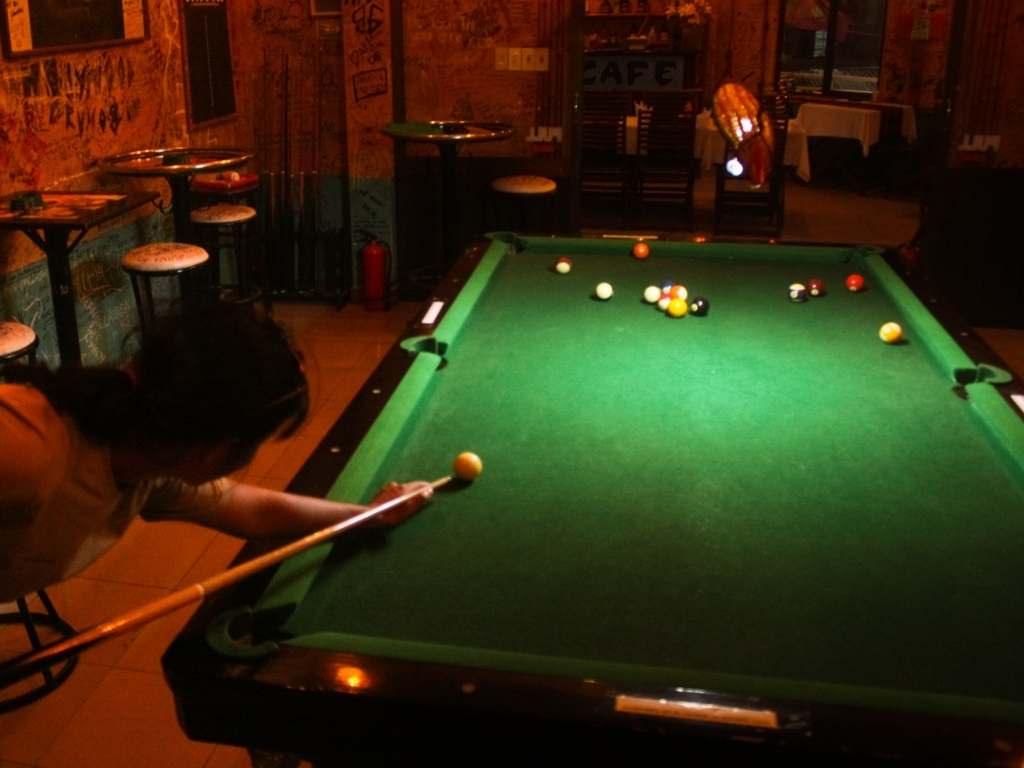What is the atmosphere of the location in the image? The image conveys a casual and relaxed atmosphere, possibly in a local bar or pub with a pool table at the center. The dim lighting and graffiti on the walls add to the informal setting. 